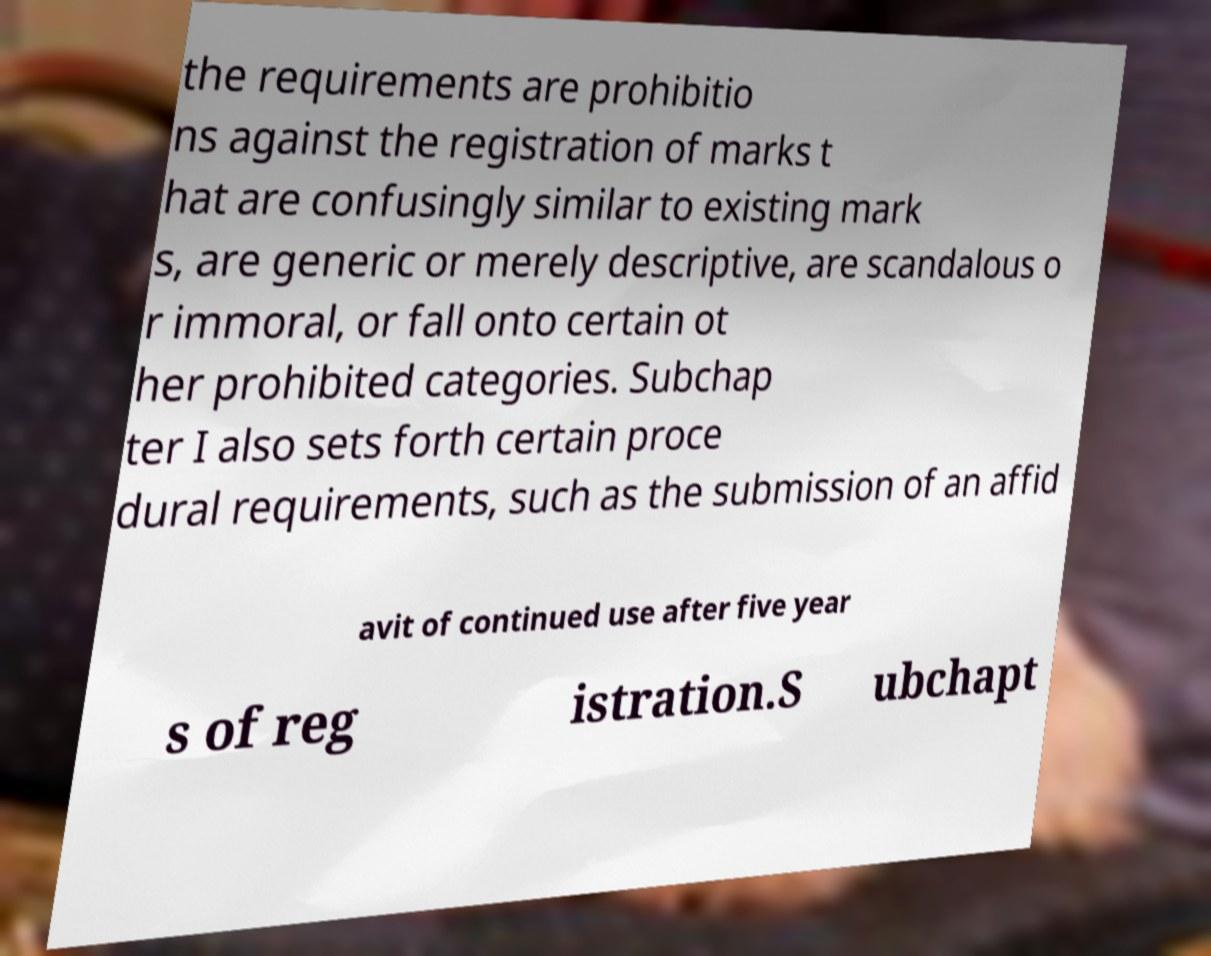Can you read and provide the text displayed in the image?This photo seems to have some interesting text. Can you extract and type it out for me? the requirements are prohibitio ns against the registration of marks t hat are confusingly similar to existing mark s, are generic or merely descriptive, are scandalous o r immoral, or fall onto certain ot her prohibited categories. Subchap ter I also sets forth certain proce dural requirements, such as the submission of an affid avit of continued use after five year s of reg istration.S ubchapt 